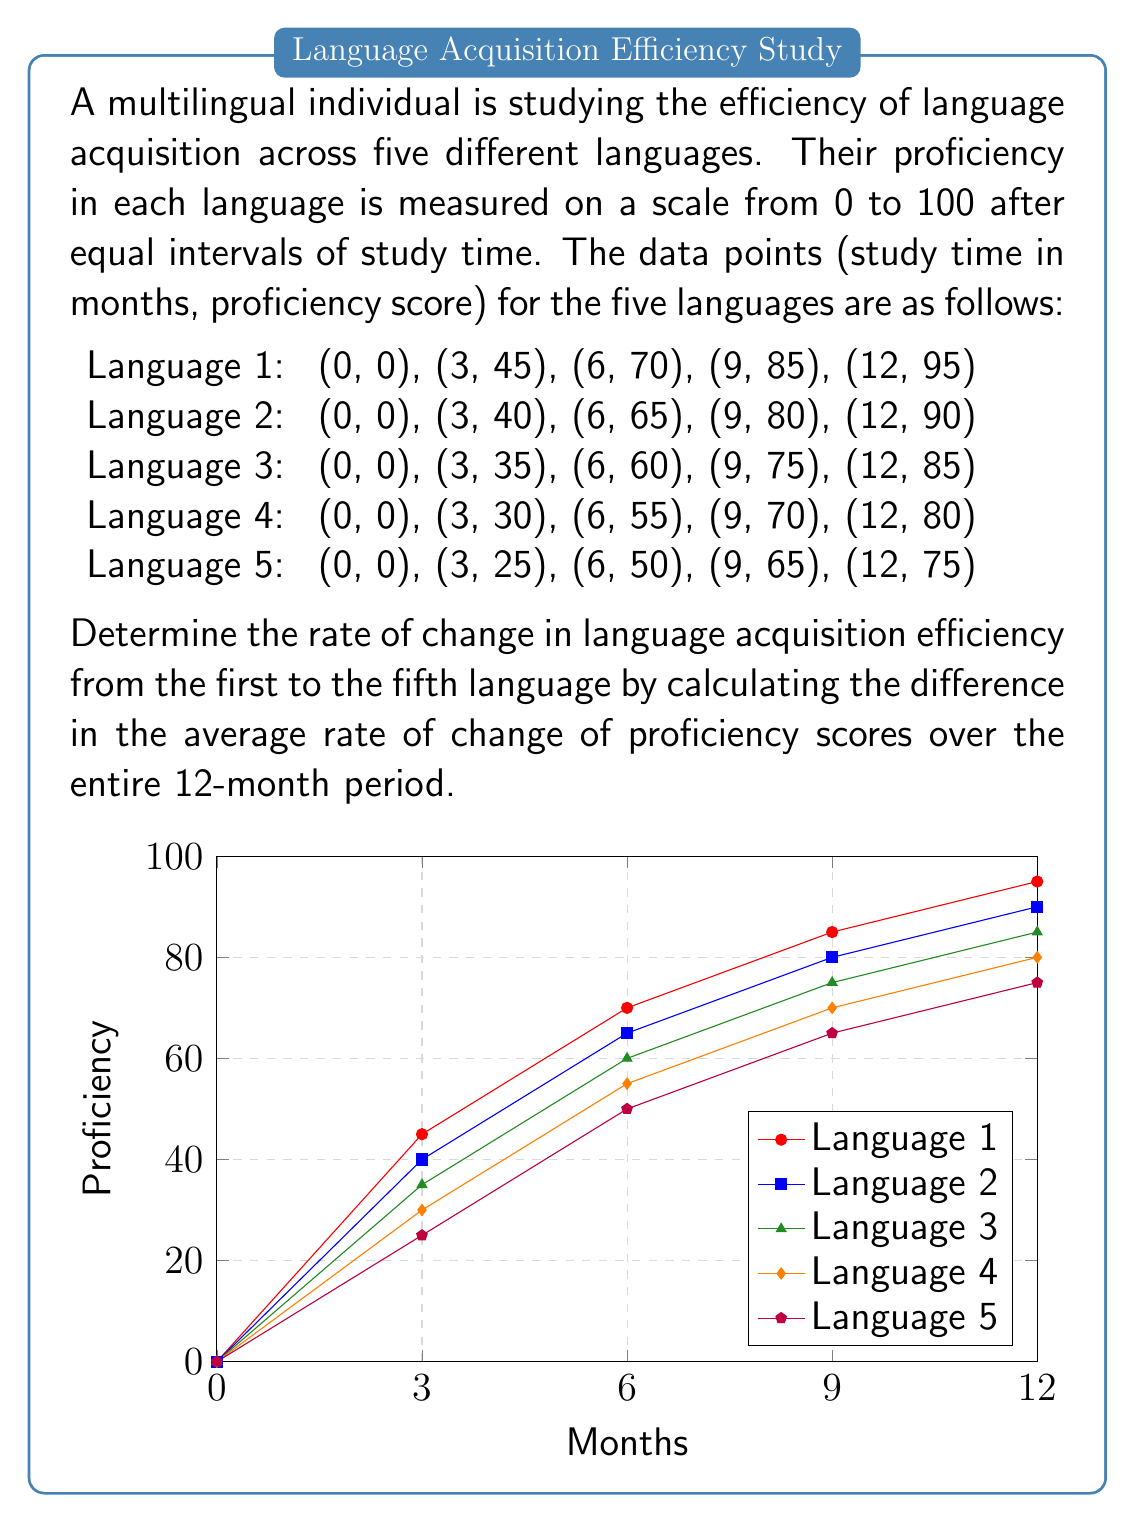Teach me how to tackle this problem. To solve this problem, we need to follow these steps:

1) Calculate the average rate of change for each language over the 12-month period.
2) Find the difference between the rates of the first and fifth languages.

Step 1: Calculating average rate of change

The average rate of change is given by the formula:

$$ \text{Average rate of change} = \frac{\text{Change in y}}{\text{Change in x}} = \frac{y_\text{final} - y_\text{initial}}{x_\text{final} - x_\text{initial}} $$

For each language:

Language 1: $\frac{95 - 0}{12 - 0} = \frac{95}{12} \approx 7.92$ points/month
Language 2: $\frac{90 - 0}{12 - 0} = \frac{90}{12} = 7.5$ points/month
Language 3: $\frac{85 - 0}{12 - 0} = \frac{85}{12} \approx 7.08$ points/month
Language 4: $\frac{80 - 0}{12 - 0} = \frac{80}{12} \approx 6.67$ points/month
Language 5: $\frac{75 - 0}{12 - 0} = \frac{75}{12} = 6.25$ points/month

Step 2: Finding the difference in rates

The rate of change in language acquisition efficiency is the difference between the rates of the first and fifth languages:

$$ \text{Rate of change} = \text{Rate}_\text{Language 1} - \text{Rate}_\text{Language 5} $$
$$ = 7.92 - 6.25 = 1.67 \text{ points/month} $$

This means that the efficiency of language acquisition decreases by approximately 1.67 points per month from the first to the fifth language.
Answer: 1.67 points/month 